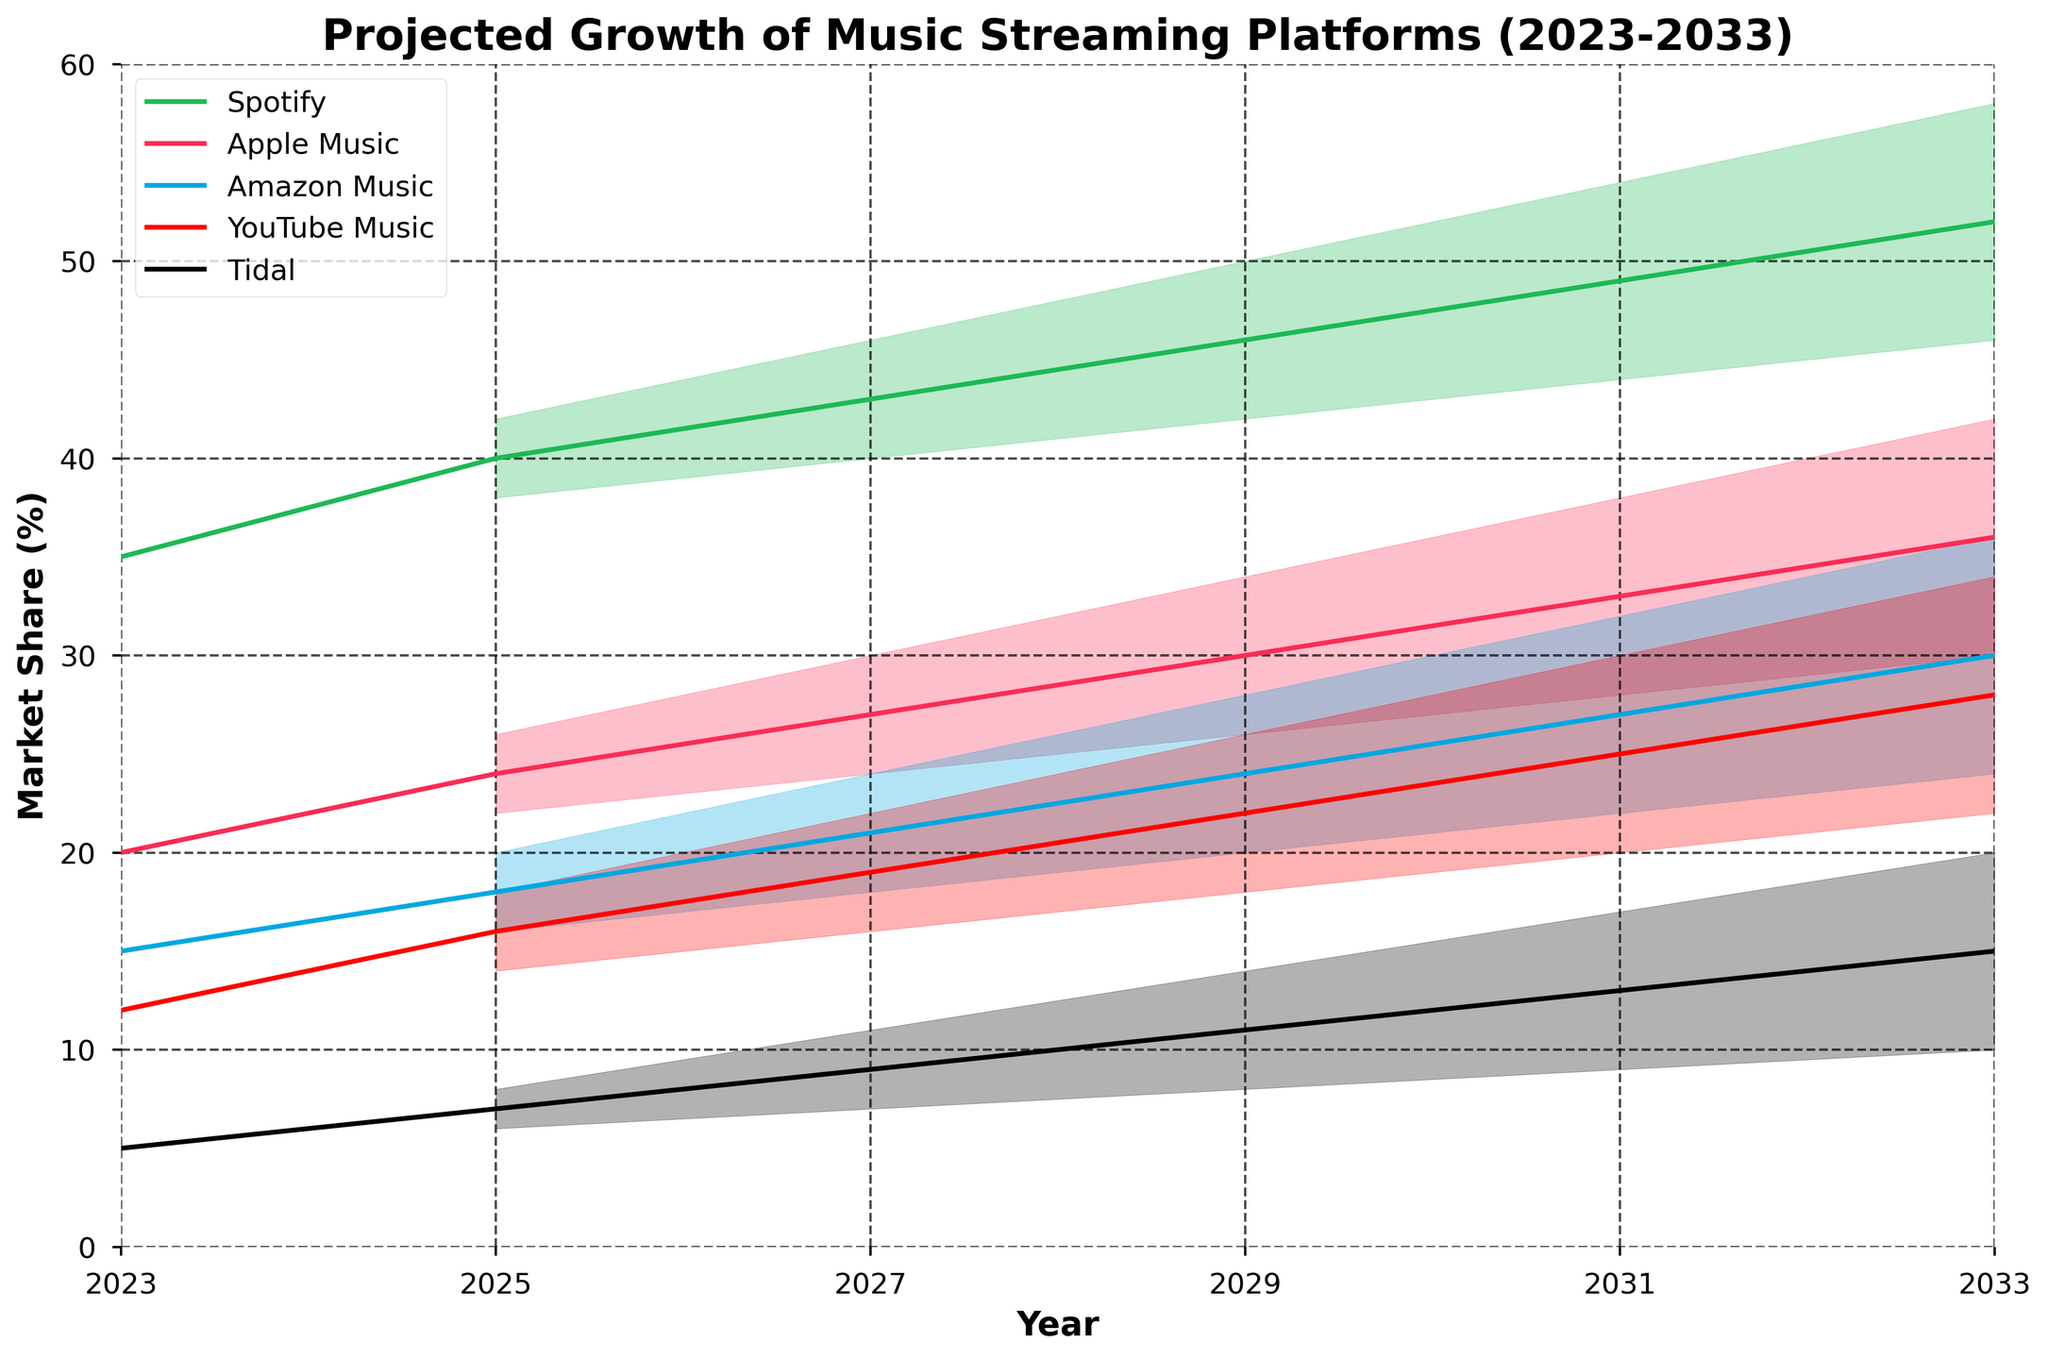What is the title of the figure? The title of the figure is typically found at the top and it gives an overview of what the chart represents. Here, the title indicates the subject of the chart.
Answer: Projected Growth of Music Streaming Platforms (2023-2033) What are the market share ranges predicted for Spotify in 2033? The market share ranges for each platform are represented by the shaded areas, with specific values indicated alongside each year. For Spotify, in 2033, the values range between 46% and 58%.
Answer: 46%-58% Which music streaming platform is projected to have the smallest market share in 2025? By examining the lower bounds of the shaded regions for each streaming service in 2025, the smallest value will indicate the platform with the least market share. Here, Tidal has the lowest market share.
Answer: Tidal How does the median market share for Apple Music change from 2027 to 2031? The median market share is represented by the central line of each shaded region. For Apple Music, comparing the central lines from 2027 to 2031, we see it progresses from around 27% to 33%.
Answer: Increases from 27% to 33% What is the color associated with YouTube Music in the figure? The figure uses specific colors to represent each streaming platform. Identifying the color for YouTube Music helps to track its projections. YouTube Music is represented in red.
Answer: Red Which platform is projected to see the highest increase in upper market share from 2023 to 2033? To determine this, examine the upper bounds of each platform’s shaded regions and compare the change from 2023 to 2033. Spotify increases from 35% to 58%, the highest increase of 23%.
Answer: Spotify Does any platform have a consistent upper market share range of over 30% across all years? This involves checking the upper bounds of each platform's shaded regions for all years. Only Spotify and Apple Music have consistent projections over 30%, but Spotify is the more consistent.
Answer: Spotify, Apple Music Compare the projected market share range of Amazon Music in 2023 and 2029. For comparison, examine both the lower and upper bounds of Amazon Music's shaded regions in these two years. In 2023 it's 15%, and in 2029 it ranges from 20% to 28%.
Answer: Widens, 15% in 2023 to 20%-28% in 2029 Which two streaming platforms have the closest median market shares in 2025? Comparing the central lines of the shaded regions for 2025 will show which two platforms are the closest. Apple Music and Amazon Music both center around 24%.
Answer: Apple Music and Amazon Music 